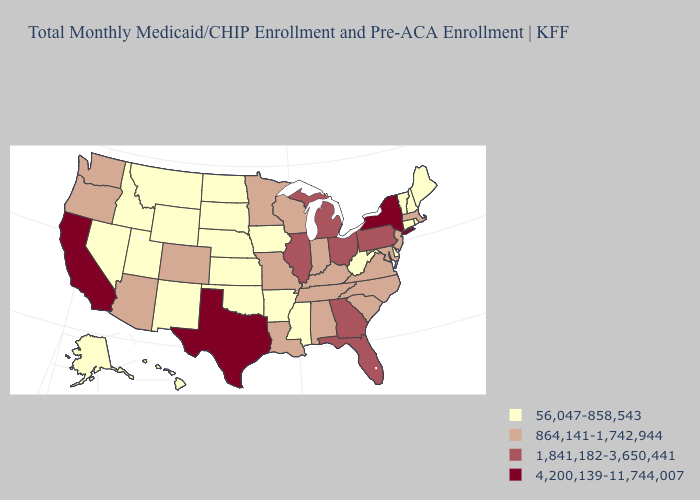Does California have the lowest value in the West?
Be succinct. No. Which states hav the highest value in the MidWest?
Quick response, please. Illinois, Michigan, Ohio. What is the highest value in the South ?
Concise answer only. 4,200,139-11,744,007. What is the value of Alabama?
Answer briefly. 864,141-1,742,944. Does Michigan have the same value as Arkansas?
Concise answer only. No. Name the states that have a value in the range 864,141-1,742,944?
Concise answer only. Alabama, Arizona, Colorado, Indiana, Kentucky, Louisiana, Maryland, Massachusetts, Minnesota, Missouri, New Jersey, North Carolina, Oregon, South Carolina, Tennessee, Virginia, Washington, Wisconsin. Name the states that have a value in the range 4,200,139-11,744,007?
Keep it brief. California, New York, Texas. What is the highest value in states that border Nevada?
Answer briefly. 4,200,139-11,744,007. What is the value of Wisconsin?
Concise answer only. 864,141-1,742,944. Is the legend a continuous bar?
Short answer required. No. What is the highest value in states that border South Carolina?
Short answer required. 1,841,182-3,650,441. Does New York have the highest value in the USA?
Write a very short answer. Yes. How many symbols are there in the legend?
Concise answer only. 4. What is the value of Hawaii?
Write a very short answer. 56,047-858,543. Does Indiana have a higher value than Illinois?
Answer briefly. No. 